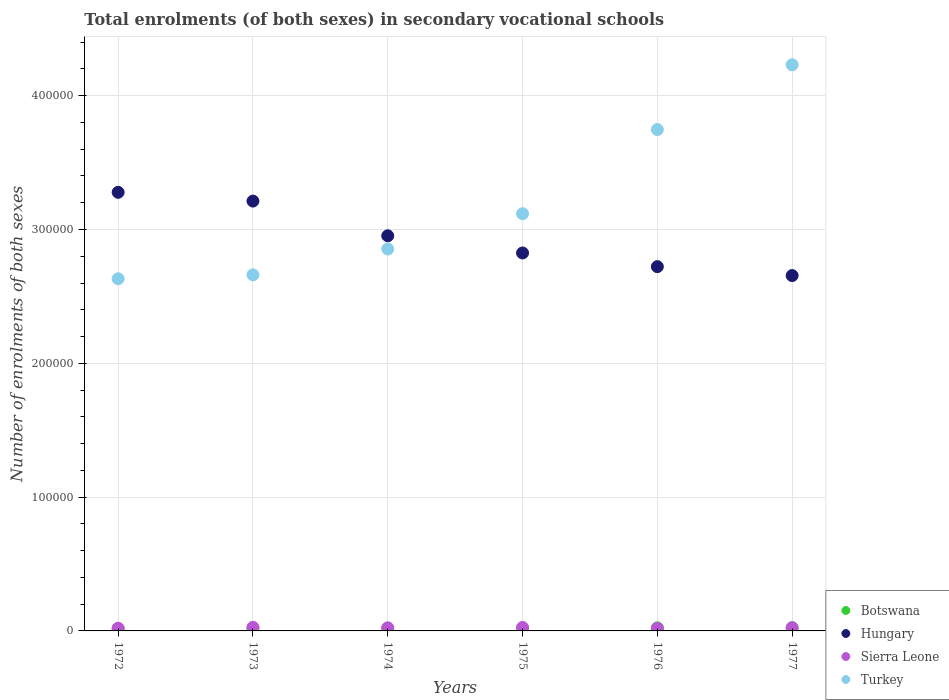What is the number of enrolments in secondary schools in Hungary in 1975?
Give a very brief answer. 2.82e+05. Across all years, what is the maximum number of enrolments in secondary schools in Hungary?
Ensure brevity in your answer.  3.28e+05. Across all years, what is the minimum number of enrolments in secondary schools in Botswana?
Your answer should be very brief. 1631. In which year was the number of enrolments in secondary schools in Sierra Leone minimum?
Make the answer very short. 1976. What is the total number of enrolments in secondary schools in Hungary in the graph?
Provide a succinct answer. 1.76e+06. What is the difference between the number of enrolments in secondary schools in Turkey in 1973 and that in 1976?
Give a very brief answer. -1.09e+05. What is the difference between the number of enrolments in secondary schools in Botswana in 1973 and the number of enrolments in secondary schools in Sierra Leone in 1974?
Provide a short and direct response. -459. What is the average number of enrolments in secondary schools in Turkey per year?
Your answer should be very brief. 3.21e+05. In the year 1973, what is the difference between the number of enrolments in secondary schools in Botswana and number of enrolments in secondary schools in Hungary?
Provide a short and direct response. -3.19e+05. What is the ratio of the number of enrolments in secondary schools in Botswana in 1973 to that in 1977?
Give a very brief answer. 0.78. Is the number of enrolments in secondary schools in Botswana in 1974 less than that in 1975?
Your response must be concise. Yes. Is the difference between the number of enrolments in secondary schools in Botswana in 1973 and 1975 greater than the difference between the number of enrolments in secondary schools in Hungary in 1973 and 1975?
Give a very brief answer. No. What is the difference between the highest and the second highest number of enrolments in secondary schools in Botswana?
Provide a succinct answer. 116. What is the difference between the highest and the lowest number of enrolments in secondary schools in Hungary?
Provide a succinct answer. 6.22e+04. In how many years, is the number of enrolments in secondary schools in Botswana greater than the average number of enrolments in secondary schools in Botswana taken over all years?
Your answer should be compact. 3. Is it the case that in every year, the sum of the number of enrolments in secondary schools in Botswana and number of enrolments in secondary schools in Sierra Leone  is greater than the sum of number of enrolments in secondary schools in Turkey and number of enrolments in secondary schools in Hungary?
Give a very brief answer. No. Is it the case that in every year, the sum of the number of enrolments in secondary schools in Sierra Leone and number of enrolments in secondary schools in Hungary  is greater than the number of enrolments in secondary schools in Turkey?
Make the answer very short. No. Does the number of enrolments in secondary schools in Botswana monotonically increase over the years?
Keep it short and to the point. Yes. Is the number of enrolments in secondary schools in Hungary strictly less than the number of enrolments in secondary schools in Turkey over the years?
Ensure brevity in your answer.  No. Are the values on the major ticks of Y-axis written in scientific E-notation?
Provide a succinct answer. No. Does the graph contain grids?
Your answer should be very brief. Yes. How many legend labels are there?
Your response must be concise. 4. How are the legend labels stacked?
Your answer should be very brief. Vertical. What is the title of the graph?
Your response must be concise. Total enrolments (of both sexes) in secondary vocational schools. Does "Luxembourg" appear as one of the legend labels in the graph?
Keep it short and to the point. No. What is the label or title of the X-axis?
Your answer should be very brief. Years. What is the label or title of the Y-axis?
Ensure brevity in your answer.  Number of enrolments of both sexes. What is the Number of enrolments of both sexes in Botswana in 1972?
Give a very brief answer. 1631. What is the Number of enrolments of both sexes in Hungary in 1972?
Make the answer very short. 3.28e+05. What is the Number of enrolments of both sexes of Sierra Leone in 1972?
Offer a very short reply. 2043. What is the Number of enrolments of both sexes in Turkey in 1972?
Offer a terse response. 2.63e+05. What is the Number of enrolments of both sexes of Botswana in 1973?
Keep it short and to the point. 1866. What is the Number of enrolments of both sexes of Hungary in 1973?
Offer a terse response. 3.21e+05. What is the Number of enrolments of both sexes in Sierra Leone in 1973?
Offer a very short reply. 2650. What is the Number of enrolments of both sexes in Turkey in 1973?
Your answer should be compact. 2.66e+05. What is the Number of enrolments of both sexes of Botswana in 1974?
Your response must be concise. 1937. What is the Number of enrolments of both sexes in Hungary in 1974?
Your response must be concise. 2.95e+05. What is the Number of enrolments of both sexes of Sierra Leone in 1974?
Keep it short and to the point. 2325. What is the Number of enrolments of both sexes in Turkey in 1974?
Give a very brief answer. 2.85e+05. What is the Number of enrolments of both sexes of Botswana in 1975?
Your answer should be very brief. 2188. What is the Number of enrolments of both sexes of Hungary in 1975?
Offer a very short reply. 2.82e+05. What is the Number of enrolments of both sexes of Sierra Leone in 1975?
Your response must be concise. 2584. What is the Number of enrolments of both sexes in Turkey in 1975?
Your response must be concise. 3.12e+05. What is the Number of enrolments of both sexes of Botswana in 1976?
Keep it short and to the point. 2284. What is the Number of enrolments of both sexes of Hungary in 1976?
Provide a succinct answer. 2.72e+05. What is the Number of enrolments of both sexes in Sierra Leone in 1976?
Offer a terse response. 1944. What is the Number of enrolments of both sexes in Turkey in 1976?
Make the answer very short. 3.75e+05. What is the Number of enrolments of both sexes of Botswana in 1977?
Make the answer very short. 2400. What is the Number of enrolments of both sexes of Hungary in 1977?
Your answer should be very brief. 2.66e+05. What is the Number of enrolments of both sexes of Sierra Leone in 1977?
Keep it short and to the point. 2349. What is the Number of enrolments of both sexes of Turkey in 1977?
Offer a very short reply. 4.23e+05. Across all years, what is the maximum Number of enrolments of both sexes of Botswana?
Offer a terse response. 2400. Across all years, what is the maximum Number of enrolments of both sexes of Hungary?
Give a very brief answer. 3.28e+05. Across all years, what is the maximum Number of enrolments of both sexes in Sierra Leone?
Provide a succinct answer. 2650. Across all years, what is the maximum Number of enrolments of both sexes of Turkey?
Offer a terse response. 4.23e+05. Across all years, what is the minimum Number of enrolments of both sexes in Botswana?
Keep it short and to the point. 1631. Across all years, what is the minimum Number of enrolments of both sexes of Hungary?
Your response must be concise. 2.66e+05. Across all years, what is the minimum Number of enrolments of both sexes in Sierra Leone?
Offer a very short reply. 1944. Across all years, what is the minimum Number of enrolments of both sexes in Turkey?
Offer a very short reply. 2.63e+05. What is the total Number of enrolments of both sexes of Botswana in the graph?
Offer a very short reply. 1.23e+04. What is the total Number of enrolments of both sexes of Hungary in the graph?
Provide a short and direct response. 1.76e+06. What is the total Number of enrolments of both sexes of Sierra Leone in the graph?
Your answer should be very brief. 1.39e+04. What is the total Number of enrolments of both sexes in Turkey in the graph?
Give a very brief answer. 1.92e+06. What is the difference between the Number of enrolments of both sexes in Botswana in 1972 and that in 1973?
Provide a short and direct response. -235. What is the difference between the Number of enrolments of both sexes in Hungary in 1972 and that in 1973?
Offer a terse response. 6551. What is the difference between the Number of enrolments of both sexes in Sierra Leone in 1972 and that in 1973?
Make the answer very short. -607. What is the difference between the Number of enrolments of both sexes in Turkey in 1972 and that in 1973?
Keep it short and to the point. -2960. What is the difference between the Number of enrolments of both sexes in Botswana in 1972 and that in 1974?
Give a very brief answer. -306. What is the difference between the Number of enrolments of both sexes in Hungary in 1972 and that in 1974?
Keep it short and to the point. 3.25e+04. What is the difference between the Number of enrolments of both sexes in Sierra Leone in 1972 and that in 1974?
Keep it short and to the point. -282. What is the difference between the Number of enrolments of both sexes of Turkey in 1972 and that in 1974?
Provide a short and direct response. -2.23e+04. What is the difference between the Number of enrolments of both sexes in Botswana in 1972 and that in 1975?
Keep it short and to the point. -557. What is the difference between the Number of enrolments of both sexes of Hungary in 1972 and that in 1975?
Make the answer very short. 4.53e+04. What is the difference between the Number of enrolments of both sexes in Sierra Leone in 1972 and that in 1975?
Your answer should be compact. -541. What is the difference between the Number of enrolments of both sexes in Turkey in 1972 and that in 1975?
Make the answer very short. -4.86e+04. What is the difference between the Number of enrolments of both sexes of Botswana in 1972 and that in 1976?
Provide a short and direct response. -653. What is the difference between the Number of enrolments of both sexes in Hungary in 1972 and that in 1976?
Ensure brevity in your answer.  5.56e+04. What is the difference between the Number of enrolments of both sexes in Turkey in 1972 and that in 1976?
Your answer should be compact. -1.12e+05. What is the difference between the Number of enrolments of both sexes of Botswana in 1972 and that in 1977?
Give a very brief answer. -769. What is the difference between the Number of enrolments of both sexes in Hungary in 1972 and that in 1977?
Make the answer very short. 6.22e+04. What is the difference between the Number of enrolments of both sexes in Sierra Leone in 1972 and that in 1977?
Provide a succinct answer. -306. What is the difference between the Number of enrolments of both sexes in Turkey in 1972 and that in 1977?
Make the answer very short. -1.60e+05. What is the difference between the Number of enrolments of both sexes of Botswana in 1973 and that in 1974?
Make the answer very short. -71. What is the difference between the Number of enrolments of both sexes in Hungary in 1973 and that in 1974?
Offer a terse response. 2.59e+04. What is the difference between the Number of enrolments of both sexes of Sierra Leone in 1973 and that in 1974?
Your answer should be compact. 325. What is the difference between the Number of enrolments of both sexes in Turkey in 1973 and that in 1974?
Offer a terse response. -1.93e+04. What is the difference between the Number of enrolments of both sexes of Botswana in 1973 and that in 1975?
Your response must be concise. -322. What is the difference between the Number of enrolments of both sexes in Hungary in 1973 and that in 1975?
Provide a short and direct response. 3.88e+04. What is the difference between the Number of enrolments of both sexes of Sierra Leone in 1973 and that in 1975?
Make the answer very short. 66. What is the difference between the Number of enrolments of both sexes in Turkey in 1973 and that in 1975?
Your answer should be compact. -4.57e+04. What is the difference between the Number of enrolments of both sexes of Botswana in 1973 and that in 1976?
Your answer should be very brief. -418. What is the difference between the Number of enrolments of both sexes in Hungary in 1973 and that in 1976?
Give a very brief answer. 4.90e+04. What is the difference between the Number of enrolments of both sexes of Sierra Leone in 1973 and that in 1976?
Your answer should be very brief. 706. What is the difference between the Number of enrolments of both sexes in Turkey in 1973 and that in 1976?
Your answer should be very brief. -1.09e+05. What is the difference between the Number of enrolments of both sexes of Botswana in 1973 and that in 1977?
Your response must be concise. -534. What is the difference between the Number of enrolments of both sexes in Hungary in 1973 and that in 1977?
Make the answer very short. 5.57e+04. What is the difference between the Number of enrolments of both sexes in Sierra Leone in 1973 and that in 1977?
Make the answer very short. 301. What is the difference between the Number of enrolments of both sexes in Turkey in 1973 and that in 1977?
Your response must be concise. -1.57e+05. What is the difference between the Number of enrolments of both sexes of Botswana in 1974 and that in 1975?
Provide a short and direct response. -251. What is the difference between the Number of enrolments of both sexes of Hungary in 1974 and that in 1975?
Your answer should be very brief. 1.28e+04. What is the difference between the Number of enrolments of both sexes of Sierra Leone in 1974 and that in 1975?
Your answer should be very brief. -259. What is the difference between the Number of enrolments of both sexes of Turkey in 1974 and that in 1975?
Your answer should be very brief. -2.64e+04. What is the difference between the Number of enrolments of both sexes in Botswana in 1974 and that in 1976?
Provide a short and direct response. -347. What is the difference between the Number of enrolments of both sexes of Hungary in 1974 and that in 1976?
Make the answer very short. 2.31e+04. What is the difference between the Number of enrolments of both sexes of Sierra Leone in 1974 and that in 1976?
Give a very brief answer. 381. What is the difference between the Number of enrolments of both sexes in Turkey in 1974 and that in 1976?
Offer a terse response. -8.93e+04. What is the difference between the Number of enrolments of both sexes of Botswana in 1974 and that in 1977?
Your response must be concise. -463. What is the difference between the Number of enrolments of both sexes of Hungary in 1974 and that in 1977?
Provide a short and direct response. 2.97e+04. What is the difference between the Number of enrolments of both sexes of Turkey in 1974 and that in 1977?
Make the answer very short. -1.38e+05. What is the difference between the Number of enrolments of both sexes in Botswana in 1975 and that in 1976?
Your answer should be very brief. -96. What is the difference between the Number of enrolments of both sexes of Hungary in 1975 and that in 1976?
Your answer should be very brief. 1.02e+04. What is the difference between the Number of enrolments of both sexes in Sierra Leone in 1975 and that in 1976?
Make the answer very short. 640. What is the difference between the Number of enrolments of both sexes of Turkey in 1975 and that in 1976?
Offer a terse response. -6.29e+04. What is the difference between the Number of enrolments of both sexes of Botswana in 1975 and that in 1977?
Keep it short and to the point. -212. What is the difference between the Number of enrolments of both sexes in Hungary in 1975 and that in 1977?
Ensure brevity in your answer.  1.69e+04. What is the difference between the Number of enrolments of both sexes of Sierra Leone in 1975 and that in 1977?
Offer a very short reply. 235. What is the difference between the Number of enrolments of both sexes in Turkey in 1975 and that in 1977?
Ensure brevity in your answer.  -1.11e+05. What is the difference between the Number of enrolments of both sexes in Botswana in 1976 and that in 1977?
Ensure brevity in your answer.  -116. What is the difference between the Number of enrolments of both sexes in Hungary in 1976 and that in 1977?
Keep it short and to the point. 6666. What is the difference between the Number of enrolments of both sexes of Sierra Leone in 1976 and that in 1977?
Offer a terse response. -405. What is the difference between the Number of enrolments of both sexes in Turkey in 1976 and that in 1977?
Offer a very short reply. -4.84e+04. What is the difference between the Number of enrolments of both sexes of Botswana in 1972 and the Number of enrolments of both sexes of Hungary in 1973?
Provide a short and direct response. -3.20e+05. What is the difference between the Number of enrolments of both sexes of Botswana in 1972 and the Number of enrolments of both sexes of Sierra Leone in 1973?
Offer a terse response. -1019. What is the difference between the Number of enrolments of both sexes of Botswana in 1972 and the Number of enrolments of both sexes of Turkey in 1973?
Offer a terse response. -2.65e+05. What is the difference between the Number of enrolments of both sexes in Hungary in 1972 and the Number of enrolments of both sexes in Sierra Leone in 1973?
Provide a short and direct response. 3.25e+05. What is the difference between the Number of enrolments of both sexes in Hungary in 1972 and the Number of enrolments of both sexes in Turkey in 1973?
Your response must be concise. 6.17e+04. What is the difference between the Number of enrolments of both sexes in Sierra Leone in 1972 and the Number of enrolments of both sexes in Turkey in 1973?
Your answer should be compact. -2.64e+05. What is the difference between the Number of enrolments of both sexes of Botswana in 1972 and the Number of enrolments of both sexes of Hungary in 1974?
Your answer should be compact. -2.94e+05. What is the difference between the Number of enrolments of both sexes of Botswana in 1972 and the Number of enrolments of both sexes of Sierra Leone in 1974?
Keep it short and to the point. -694. What is the difference between the Number of enrolments of both sexes of Botswana in 1972 and the Number of enrolments of both sexes of Turkey in 1974?
Your answer should be compact. -2.84e+05. What is the difference between the Number of enrolments of both sexes in Hungary in 1972 and the Number of enrolments of both sexes in Sierra Leone in 1974?
Keep it short and to the point. 3.25e+05. What is the difference between the Number of enrolments of both sexes in Hungary in 1972 and the Number of enrolments of both sexes in Turkey in 1974?
Provide a succinct answer. 4.24e+04. What is the difference between the Number of enrolments of both sexes in Sierra Leone in 1972 and the Number of enrolments of both sexes in Turkey in 1974?
Offer a very short reply. -2.83e+05. What is the difference between the Number of enrolments of both sexes of Botswana in 1972 and the Number of enrolments of both sexes of Hungary in 1975?
Give a very brief answer. -2.81e+05. What is the difference between the Number of enrolments of both sexes in Botswana in 1972 and the Number of enrolments of both sexes in Sierra Leone in 1975?
Offer a very short reply. -953. What is the difference between the Number of enrolments of both sexes in Botswana in 1972 and the Number of enrolments of both sexes in Turkey in 1975?
Provide a succinct answer. -3.10e+05. What is the difference between the Number of enrolments of both sexes of Hungary in 1972 and the Number of enrolments of both sexes of Sierra Leone in 1975?
Provide a succinct answer. 3.25e+05. What is the difference between the Number of enrolments of both sexes in Hungary in 1972 and the Number of enrolments of both sexes in Turkey in 1975?
Provide a short and direct response. 1.60e+04. What is the difference between the Number of enrolments of both sexes in Sierra Leone in 1972 and the Number of enrolments of both sexes in Turkey in 1975?
Your response must be concise. -3.10e+05. What is the difference between the Number of enrolments of both sexes in Botswana in 1972 and the Number of enrolments of both sexes in Hungary in 1976?
Provide a short and direct response. -2.71e+05. What is the difference between the Number of enrolments of both sexes in Botswana in 1972 and the Number of enrolments of both sexes in Sierra Leone in 1976?
Offer a terse response. -313. What is the difference between the Number of enrolments of both sexes in Botswana in 1972 and the Number of enrolments of both sexes in Turkey in 1976?
Make the answer very short. -3.73e+05. What is the difference between the Number of enrolments of both sexes in Hungary in 1972 and the Number of enrolments of both sexes in Sierra Leone in 1976?
Make the answer very short. 3.26e+05. What is the difference between the Number of enrolments of both sexes of Hungary in 1972 and the Number of enrolments of both sexes of Turkey in 1976?
Ensure brevity in your answer.  -4.69e+04. What is the difference between the Number of enrolments of both sexes in Sierra Leone in 1972 and the Number of enrolments of both sexes in Turkey in 1976?
Provide a short and direct response. -3.73e+05. What is the difference between the Number of enrolments of both sexes of Botswana in 1972 and the Number of enrolments of both sexes of Hungary in 1977?
Keep it short and to the point. -2.64e+05. What is the difference between the Number of enrolments of both sexes in Botswana in 1972 and the Number of enrolments of both sexes in Sierra Leone in 1977?
Make the answer very short. -718. What is the difference between the Number of enrolments of both sexes in Botswana in 1972 and the Number of enrolments of both sexes in Turkey in 1977?
Your response must be concise. -4.21e+05. What is the difference between the Number of enrolments of both sexes in Hungary in 1972 and the Number of enrolments of both sexes in Sierra Leone in 1977?
Keep it short and to the point. 3.25e+05. What is the difference between the Number of enrolments of both sexes of Hungary in 1972 and the Number of enrolments of both sexes of Turkey in 1977?
Give a very brief answer. -9.53e+04. What is the difference between the Number of enrolments of both sexes in Sierra Leone in 1972 and the Number of enrolments of both sexes in Turkey in 1977?
Make the answer very short. -4.21e+05. What is the difference between the Number of enrolments of both sexes of Botswana in 1973 and the Number of enrolments of both sexes of Hungary in 1974?
Give a very brief answer. -2.93e+05. What is the difference between the Number of enrolments of both sexes in Botswana in 1973 and the Number of enrolments of both sexes in Sierra Leone in 1974?
Offer a very short reply. -459. What is the difference between the Number of enrolments of both sexes of Botswana in 1973 and the Number of enrolments of both sexes of Turkey in 1974?
Your response must be concise. -2.84e+05. What is the difference between the Number of enrolments of both sexes of Hungary in 1973 and the Number of enrolments of both sexes of Sierra Leone in 1974?
Your answer should be compact. 3.19e+05. What is the difference between the Number of enrolments of both sexes of Hungary in 1973 and the Number of enrolments of both sexes of Turkey in 1974?
Your response must be concise. 3.58e+04. What is the difference between the Number of enrolments of both sexes of Sierra Leone in 1973 and the Number of enrolments of both sexes of Turkey in 1974?
Provide a short and direct response. -2.83e+05. What is the difference between the Number of enrolments of both sexes of Botswana in 1973 and the Number of enrolments of both sexes of Hungary in 1975?
Offer a terse response. -2.81e+05. What is the difference between the Number of enrolments of both sexes of Botswana in 1973 and the Number of enrolments of both sexes of Sierra Leone in 1975?
Offer a very short reply. -718. What is the difference between the Number of enrolments of both sexes of Botswana in 1973 and the Number of enrolments of both sexes of Turkey in 1975?
Offer a very short reply. -3.10e+05. What is the difference between the Number of enrolments of both sexes of Hungary in 1973 and the Number of enrolments of both sexes of Sierra Leone in 1975?
Your answer should be very brief. 3.19e+05. What is the difference between the Number of enrolments of both sexes of Hungary in 1973 and the Number of enrolments of both sexes of Turkey in 1975?
Provide a short and direct response. 9452. What is the difference between the Number of enrolments of both sexes of Sierra Leone in 1973 and the Number of enrolments of both sexes of Turkey in 1975?
Your answer should be very brief. -3.09e+05. What is the difference between the Number of enrolments of both sexes in Botswana in 1973 and the Number of enrolments of both sexes in Hungary in 1976?
Provide a short and direct response. -2.70e+05. What is the difference between the Number of enrolments of both sexes in Botswana in 1973 and the Number of enrolments of both sexes in Sierra Leone in 1976?
Offer a very short reply. -78. What is the difference between the Number of enrolments of both sexes of Botswana in 1973 and the Number of enrolments of both sexes of Turkey in 1976?
Your response must be concise. -3.73e+05. What is the difference between the Number of enrolments of both sexes in Hungary in 1973 and the Number of enrolments of both sexes in Sierra Leone in 1976?
Your response must be concise. 3.19e+05. What is the difference between the Number of enrolments of both sexes in Hungary in 1973 and the Number of enrolments of both sexes in Turkey in 1976?
Your response must be concise. -5.35e+04. What is the difference between the Number of enrolments of both sexes of Sierra Leone in 1973 and the Number of enrolments of both sexes of Turkey in 1976?
Make the answer very short. -3.72e+05. What is the difference between the Number of enrolments of both sexes in Botswana in 1973 and the Number of enrolments of both sexes in Hungary in 1977?
Provide a short and direct response. -2.64e+05. What is the difference between the Number of enrolments of both sexes of Botswana in 1973 and the Number of enrolments of both sexes of Sierra Leone in 1977?
Keep it short and to the point. -483. What is the difference between the Number of enrolments of both sexes of Botswana in 1973 and the Number of enrolments of both sexes of Turkey in 1977?
Provide a short and direct response. -4.21e+05. What is the difference between the Number of enrolments of both sexes in Hungary in 1973 and the Number of enrolments of both sexes in Sierra Leone in 1977?
Offer a terse response. 3.19e+05. What is the difference between the Number of enrolments of both sexes of Hungary in 1973 and the Number of enrolments of both sexes of Turkey in 1977?
Provide a succinct answer. -1.02e+05. What is the difference between the Number of enrolments of both sexes in Sierra Leone in 1973 and the Number of enrolments of both sexes in Turkey in 1977?
Your response must be concise. -4.20e+05. What is the difference between the Number of enrolments of both sexes in Botswana in 1974 and the Number of enrolments of both sexes in Hungary in 1975?
Ensure brevity in your answer.  -2.81e+05. What is the difference between the Number of enrolments of both sexes in Botswana in 1974 and the Number of enrolments of both sexes in Sierra Leone in 1975?
Your answer should be very brief. -647. What is the difference between the Number of enrolments of both sexes of Botswana in 1974 and the Number of enrolments of both sexes of Turkey in 1975?
Provide a succinct answer. -3.10e+05. What is the difference between the Number of enrolments of both sexes in Hungary in 1974 and the Number of enrolments of both sexes in Sierra Leone in 1975?
Your response must be concise. 2.93e+05. What is the difference between the Number of enrolments of both sexes of Hungary in 1974 and the Number of enrolments of both sexes of Turkey in 1975?
Your answer should be compact. -1.65e+04. What is the difference between the Number of enrolments of both sexes of Sierra Leone in 1974 and the Number of enrolments of both sexes of Turkey in 1975?
Ensure brevity in your answer.  -3.09e+05. What is the difference between the Number of enrolments of both sexes of Botswana in 1974 and the Number of enrolments of both sexes of Hungary in 1976?
Give a very brief answer. -2.70e+05. What is the difference between the Number of enrolments of both sexes of Botswana in 1974 and the Number of enrolments of both sexes of Turkey in 1976?
Ensure brevity in your answer.  -3.73e+05. What is the difference between the Number of enrolments of both sexes in Hungary in 1974 and the Number of enrolments of both sexes in Sierra Leone in 1976?
Offer a very short reply. 2.93e+05. What is the difference between the Number of enrolments of both sexes in Hungary in 1974 and the Number of enrolments of both sexes in Turkey in 1976?
Make the answer very short. -7.94e+04. What is the difference between the Number of enrolments of both sexes in Sierra Leone in 1974 and the Number of enrolments of both sexes in Turkey in 1976?
Keep it short and to the point. -3.72e+05. What is the difference between the Number of enrolments of both sexes in Botswana in 1974 and the Number of enrolments of both sexes in Hungary in 1977?
Make the answer very short. -2.64e+05. What is the difference between the Number of enrolments of both sexes in Botswana in 1974 and the Number of enrolments of both sexes in Sierra Leone in 1977?
Provide a short and direct response. -412. What is the difference between the Number of enrolments of both sexes of Botswana in 1974 and the Number of enrolments of both sexes of Turkey in 1977?
Offer a very short reply. -4.21e+05. What is the difference between the Number of enrolments of both sexes of Hungary in 1974 and the Number of enrolments of both sexes of Sierra Leone in 1977?
Provide a succinct answer. 2.93e+05. What is the difference between the Number of enrolments of both sexes in Hungary in 1974 and the Number of enrolments of both sexes in Turkey in 1977?
Provide a succinct answer. -1.28e+05. What is the difference between the Number of enrolments of both sexes in Sierra Leone in 1974 and the Number of enrolments of both sexes in Turkey in 1977?
Your answer should be very brief. -4.21e+05. What is the difference between the Number of enrolments of both sexes of Botswana in 1975 and the Number of enrolments of both sexes of Hungary in 1976?
Your answer should be very brief. -2.70e+05. What is the difference between the Number of enrolments of both sexes in Botswana in 1975 and the Number of enrolments of both sexes in Sierra Leone in 1976?
Provide a short and direct response. 244. What is the difference between the Number of enrolments of both sexes in Botswana in 1975 and the Number of enrolments of both sexes in Turkey in 1976?
Offer a terse response. -3.73e+05. What is the difference between the Number of enrolments of both sexes in Hungary in 1975 and the Number of enrolments of both sexes in Sierra Leone in 1976?
Offer a very short reply. 2.81e+05. What is the difference between the Number of enrolments of both sexes in Hungary in 1975 and the Number of enrolments of both sexes in Turkey in 1976?
Offer a terse response. -9.22e+04. What is the difference between the Number of enrolments of both sexes in Sierra Leone in 1975 and the Number of enrolments of both sexes in Turkey in 1976?
Provide a succinct answer. -3.72e+05. What is the difference between the Number of enrolments of both sexes in Botswana in 1975 and the Number of enrolments of both sexes in Hungary in 1977?
Make the answer very short. -2.63e+05. What is the difference between the Number of enrolments of both sexes in Botswana in 1975 and the Number of enrolments of both sexes in Sierra Leone in 1977?
Your answer should be compact. -161. What is the difference between the Number of enrolments of both sexes in Botswana in 1975 and the Number of enrolments of both sexes in Turkey in 1977?
Provide a short and direct response. -4.21e+05. What is the difference between the Number of enrolments of both sexes in Hungary in 1975 and the Number of enrolments of both sexes in Sierra Leone in 1977?
Offer a terse response. 2.80e+05. What is the difference between the Number of enrolments of both sexes in Hungary in 1975 and the Number of enrolments of both sexes in Turkey in 1977?
Offer a very short reply. -1.41e+05. What is the difference between the Number of enrolments of both sexes in Sierra Leone in 1975 and the Number of enrolments of both sexes in Turkey in 1977?
Give a very brief answer. -4.21e+05. What is the difference between the Number of enrolments of both sexes of Botswana in 1976 and the Number of enrolments of both sexes of Hungary in 1977?
Ensure brevity in your answer.  -2.63e+05. What is the difference between the Number of enrolments of both sexes of Botswana in 1976 and the Number of enrolments of both sexes of Sierra Leone in 1977?
Your answer should be very brief. -65. What is the difference between the Number of enrolments of both sexes in Botswana in 1976 and the Number of enrolments of both sexes in Turkey in 1977?
Make the answer very short. -4.21e+05. What is the difference between the Number of enrolments of both sexes in Hungary in 1976 and the Number of enrolments of both sexes in Sierra Leone in 1977?
Offer a terse response. 2.70e+05. What is the difference between the Number of enrolments of both sexes in Hungary in 1976 and the Number of enrolments of both sexes in Turkey in 1977?
Make the answer very short. -1.51e+05. What is the difference between the Number of enrolments of both sexes in Sierra Leone in 1976 and the Number of enrolments of both sexes in Turkey in 1977?
Ensure brevity in your answer.  -4.21e+05. What is the average Number of enrolments of both sexes in Botswana per year?
Make the answer very short. 2051. What is the average Number of enrolments of both sexes of Hungary per year?
Offer a very short reply. 2.94e+05. What is the average Number of enrolments of both sexes of Sierra Leone per year?
Ensure brevity in your answer.  2315.83. What is the average Number of enrolments of both sexes in Turkey per year?
Give a very brief answer. 3.21e+05. In the year 1972, what is the difference between the Number of enrolments of both sexes of Botswana and Number of enrolments of both sexes of Hungary?
Your answer should be very brief. -3.26e+05. In the year 1972, what is the difference between the Number of enrolments of both sexes in Botswana and Number of enrolments of both sexes in Sierra Leone?
Your response must be concise. -412. In the year 1972, what is the difference between the Number of enrolments of both sexes of Botswana and Number of enrolments of both sexes of Turkey?
Keep it short and to the point. -2.62e+05. In the year 1972, what is the difference between the Number of enrolments of both sexes of Hungary and Number of enrolments of both sexes of Sierra Leone?
Offer a terse response. 3.26e+05. In the year 1972, what is the difference between the Number of enrolments of both sexes of Hungary and Number of enrolments of both sexes of Turkey?
Provide a succinct answer. 6.46e+04. In the year 1972, what is the difference between the Number of enrolments of both sexes of Sierra Leone and Number of enrolments of both sexes of Turkey?
Your response must be concise. -2.61e+05. In the year 1973, what is the difference between the Number of enrolments of both sexes of Botswana and Number of enrolments of both sexes of Hungary?
Your response must be concise. -3.19e+05. In the year 1973, what is the difference between the Number of enrolments of both sexes in Botswana and Number of enrolments of both sexes in Sierra Leone?
Provide a succinct answer. -784. In the year 1973, what is the difference between the Number of enrolments of both sexes in Botswana and Number of enrolments of both sexes in Turkey?
Make the answer very short. -2.64e+05. In the year 1973, what is the difference between the Number of enrolments of both sexes of Hungary and Number of enrolments of both sexes of Sierra Leone?
Give a very brief answer. 3.19e+05. In the year 1973, what is the difference between the Number of enrolments of both sexes in Hungary and Number of enrolments of both sexes in Turkey?
Give a very brief answer. 5.51e+04. In the year 1973, what is the difference between the Number of enrolments of both sexes of Sierra Leone and Number of enrolments of both sexes of Turkey?
Your answer should be compact. -2.63e+05. In the year 1974, what is the difference between the Number of enrolments of both sexes of Botswana and Number of enrolments of both sexes of Hungary?
Keep it short and to the point. -2.93e+05. In the year 1974, what is the difference between the Number of enrolments of both sexes in Botswana and Number of enrolments of both sexes in Sierra Leone?
Make the answer very short. -388. In the year 1974, what is the difference between the Number of enrolments of both sexes in Botswana and Number of enrolments of both sexes in Turkey?
Your answer should be compact. -2.84e+05. In the year 1974, what is the difference between the Number of enrolments of both sexes in Hungary and Number of enrolments of both sexes in Sierra Leone?
Offer a very short reply. 2.93e+05. In the year 1974, what is the difference between the Number of enrolments of both sexes of Hungary and Number of enrolments of both sexes of Turkey?
Ensure brevity in your answer.  9862. In the year 1974, what is the difference between the Number of enrolments of both sexes in Sierra Leone and Number of enrolments of both sexes in Turkey?
Keep it short and to the point. -2.83e+05. In the year 1975, what is the difference between the Number of enrolments of both sexes of Botswana and Number of enrolments of both sexes of Hungary?
Give a very brief answer. -2.80e+05. In the year 1975, what is the difference between the Number of enrolments of both sexes in Botswana and Number of enrolments of both sexes in Sierra Leone?
Keep it short and to the point. -396. In the year 1975, what is the difference between the Number of enrolments of both sexes in Botswana and Number of enrolments of both sexes in Turkey?
Provide a short and direct response. -3.10e+05. In the year 1975, what is the difference between the Number of enrolments of both sexes of Hungary and Number of enrolments of both sexes of Sierra Leone?
Make the answer very short. 2.80e+05. In the year 1975, what is the difference between the Number of enrolments of both sexes in Hungary and Number of enrolments of both sexes in Turkey?
Your response must be concise. -2.93e+04. In the year 1975, what is the difference between the Number of enrolments of both sexes in Sierra Leone and Number of enrolments of both sexes in Turkey?
Offer a very short reply. -3.09e+05. In the year 1976, what is the difference between the Number of enrolments of both sexes in Botswana and Number of enrolments of both sexes in Hungary?
Your answer should be very brief. -2.70e+05. In the year 1976, what is the difference between the Number of enrolments of both sexes of Botswana and Number of enrolments of both sexes of Sierra Leone?
Provide a short and direct response. 340. In the year 1976, what is the difference between the Number of enrolments of both sexes of Botswana and Number of enrolments of both sexes of Turkey?
Keep it short and to the point. -3.72e+05. In the year 1976, what is the difference between the Number of enrolments of both sexes in Hungary and Number of enrolments of both sexes in Sierra Leone?
Keep it short and to the point. 2.70e+05. In the year 1976, what is the difference between the Number of enrolments of both sexes in Hungary and Number of enrolments of both sexes in Turkey?
Give a very brief answer. -1.02e+05. In the year 1976, what is the difference between the Number of enrolments of both sexes of Sierra Leone and Number of enrolments of both sexes of Turkey?
Ensure brevity in your answer.  -3.73e+05. In the year 1977, what is the difference between the Number of enrolments of both sexes in Botswana and Number of enrolments of both sexes in Hungary?
Your response must be concise. -2.63e+05. In the year 1977, what is the difference between the Number of enrolments of both sexes in Botswana and Number of enrolments of both sexes in Sierra Leone?
Your response must be concise. 51. In the year 1977, what is the difference between the Number of enrolments of both sexes in Botswana and Number of enrolments of both sexes in Turkey?
Your response must be concise. -4.21e+05. In the year 1977, what is the difference between the Number of enrolments of both sexes of Hungary and Number of enrolments of both sexes of Sierra Leone?
Keep it short and to the point. 2.63e+05. In the year 1977, what is the difference between the Number of enrolments of both sexes of Hungary and Number of enrolments of both sexes of Turkey?
Your answer should be very brief. -1.58e+05. In the year 1977, what is the difference between the Number of enrolments of both sexes of Sierra Leone and Number of enrolments of both sexes of Turkey?
Make the answer very short. -4.21e+05. What is the ratio of the Number of enrolments of both sexes of Botswana in 1972 to that in 1973?
Offer a terse response. 0.87. What is the ratio of the Number of enrolments of both sexes of Hungary in 1972 to that in 1973?
Make the answer very short. 1.02. What is the ratio of the Number of enrolments of both sexes of Sierra Leone in 1972 to that in 1973?
Provide a succinct answer. 0.77. What is the ratio of the Number of enrolments of both sexes of Turkey in 1972 to that in 1973?
Your answer should be very brief. 0.99. What is the ratio of the Number of enrolments of both sexes in Botswana in 1972 to that in 1974?
Offer a very short reply. 0.84. What is the ratio of the Number of enrolments of both sexes in Hungary in 1972 to that in 1974?
Give a very brief answer. 1.11. What is the ratio of the Number of enrolments of both sexes of Sierra Leone in 1972 to that in 1974?
Provide a succinct answer. 0.88. What is the ratio of the Number of enrolments of both sexes in Turkey in 1972 to that in 1974?
Provide a succinct answer. 0.92. What is the ratio of the Number of enrolments of both sexes in Botswana in 1972 to that in 1975?
Offer a terse response. 0.75. What is the ratio of the Number of enrolments of both sexes of Hungary in 1972 to that in 1975?
Keep it short and to the point. 1.16. What is the ratio of the Number of enrolments of both sexes of Sierra Leone in 1972 to that in 1975?
Make the answer very short. 0.79. What is the ratio of the Number of enrolments of both sexes of Turkey in 1972 to that in 1975?
Provide a succinct answer. 0.84. What is the ratio of the Number of enrolments of both sexes in Botswana in 1972 to that in 1976?
Provide a short and direct response. 0.71. What is the ratio of the Number of enrolments of both sexes in Hungary in 1972 to that in 1976?
Provide a succinct answer. 1.2. What is the ratio of the Number of enrolments of both sexes of Sierra Leone in 1972 to that in 1976?
Make the answer very short. 1.05. What is the ratio of the Number of enrolments of both sexes of Turkey in 1972 to that in 1976?
Provide a short and direct response. 0.7. What is the ratio of the Number of enrolments of both sexes in Botswana in 1972 to that in 1977?
Keep it short and to the point. 0.68. What is the ratio of the Number of enrolments of both sexes of Hungary in 1972 to that in 1977?
Offer a very short reply. 1.23. What is the ratio of the Number of enrolments of both sexes in Sierra Leone in 1972 to that in 1977?
Ensure brevity in your answer.  0.87. What is the ratio of the Number of enrolments of both sexes in Turkey in 1972 to that in 1977?
Offer a terse response. 0.62. What is the ratio of the Number of enrolments of both sexes of Botswana in 1973 to that in 1974?
Keep it short and to the point. 0.96. What is the ratio of the Number of enrolments of both sexes of Hungary in 1973 to that in 1974?
Offer a very short reply. 1.09. What is the ratio of the Number of enrolments of both sexes in Sierra Leone in 1973 to that in 1974?
Give a very brief answer. 1.14. What is the ratio of the Number of enrolments of both sexes in Turkey in 1973 to that in 1974?
Your response must be concise. 0.93. What is the ratio of the Number of enrolments of both sexes in Botswana in 1973 to that in 1975?
Ensure brevity in your answer.  0.85. What is the ratio of the Number of enrolments of both sexes in Hungary in 1973 to that in 1975?
Offer a terse response. 1.14. What is the ratio of the Number of enrolments of both sexes of Sierra Leone in 1973 to that in 1975?
Your answer should be very brief. 1.03. What is the ratio of the Number of enrolments of both sexes of Turkey in 1973 to that in 1975?
Offer a terse response. 0.85. What is the ratio of the Number of enrolments of both sexes in Botswana in 1973 to that in 1976?
Your answer should be very brief. 0.82. What is the ratio of the Number of enrolments of both sexes of Hungary in 1973 to that in 1976?
Your answer should be compact. 1.18. What is the ratio of the Number of enrolments of both sexes of Sierra Leone in 1973 to that in 1976?
Make the answer very short. 1.36. What is the ratio of the Number of enrolments of both sexes in Turkey in 1973 to that in 1976?
Provide a short and direct response. 0.71. What is the ratio of the Number of enrolments of both sexes in Botswana in 1973 to that in 1977?
Your response must be concise. 0.78. What is the ratio of the Number of enrolments of both sexes in Hungary in 1973 to that in 1977?
Your answer should be compact. 1.21. What is the ratio of the Number of enrolments of both sexes of Sierra Leone in 1973 to that in 1977?
Keep it short and to the point. 1.13. What is the ratio of the Number of enrolments of both sexes in Turkey in 1973 to that in 1977?
Offer a terse response. 0.63. What is the ratio of the Number of enrolments of both sexes of Botswana in 1974 to that in 1975?
Keep it short and to the point. 0.89. What is the ratio of the Number of enrolments of both sexes in Hungary in 1974 to that in 1975?
Give a very brief answer. 1.05. What is the ratio of the Number of enrolments of both sexes of Sierra Leone in 1974 to that in 1975?
Ensure brevity in your answer.  0.9. What is the ratio of the Number of enrolments of both sexes of Turkey in 1974 to that in 1975?
Make the answer very short. 0.92. What is the ratio of the Number of enrolments of both sexes in Botswana in 1974 to that in 1976?
Offer a terse response. 0.85. What is the ratio of the Number of enrolments of both sexes of Hungary in 1974 to that in 1976?
Provide a succinct answer. 1.08. What is the ratio of the Number of enrolments of both sexes in Sierra Leone in 1974 to that in 1976?
Your answer should be very brief. 1.2. What is the ratio of the Number of enrolments of both sexes of Turkey in 1974 to that in 1976?
Provide a short and direct response. 0.76. What is the ratio of the Number of enrolments of both sexes of Botswana in 1974 to that in 1977?
Ensure brevity in your answer.  0.81. What is the ratio of the Number of enrolments of both sexes in Hungary in 1974 to that in 1977?
Offer a very short reply. 1.11. What is the ratio of the Number of enrolments of both sexes in Turkey in 1974 to that in 1977?
Keep it short and to the point. 0.67. What is the ratio of the Number of enrolments of both sexes in Botswana in 1975 to that in 1976?
Your answer should be very brief. 0.96. What is the ratio of the Number of enrolments of both sexes of Hungary in 1975 to that in 1976?
Make the answer very short. 1.04. What is the ratio of the Number of enrolments of both sexes of Sierra Leone in 1975 to that in 1976?
Offer a very short reply. 1.33. What is the ratio of the Number of enrolments of both sexes in Turkey in 1975 to that in 1976?
Your response must be concise. 0.83. What is the ratio of the Number of enrolments of both sexes of Botswana in 1975 to that in 1977?
Offer a terse response. 0.91. What is the ratio of the Number of enrolments of both sexes in Hungary in 1975 to that in 1977?
Provide a succinct answer. 1.06. What is the ratio of the Number of enrolments of both sexes of Turkey in 1975 to that in 1977?
Make the answer very short. 0.74. What is the ratio of the Number of enrolments of both sexes in Botswana in 1976 to that in 1977?
Provide a short and direct response. 0.95. What is the ratio of the Number of enrolments of both sexes of Hungary in 1976 to that in 1977?
Your answer should be very brief. 1.03. What is the ratio of the Number of enrolments of both sexes of Sierra Leone in 1976 to that in 1977?
Ensure brevity in your answer.  0.83. What is the ratio of the Number of enrolments of both sexes of Turkey in 1976 to that in 1977?
Give a very brief answer. 0.89. What is the difference between the highest and the second highest Number of enrolments of both sexes of Botswana?
Your answer should be compact. 116. What is the difference between the highest and the second highest Number of enrolments of both sexes of Hungary?
Make the answer very short. 6551. What is the difference between the highest and the second highest Number of enrolments of both sexes in Turkey?
Provide a short and direct response. 4.84e+04. What is the difference between the highest and the lowest Number of enrolments of both sexes in Botswana?
Make the answer very short. 769. What is the difference between the highest and the lowest Number of enrolments of both sexes in Hungary?
Give a very brief answer. 6.22e+04. What is the difference between the highest and the lowest Number of enrolments of both sexes in Sierra Leone?
Offer a terse response. 706. What is the difference between the highest and the lowest Number of enrolments of both sexes of Turkey?
Give a very brief answer. 1.60e+05. 